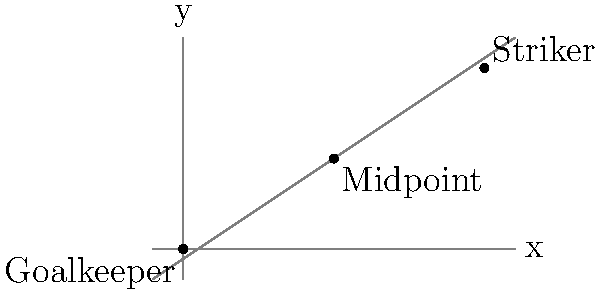In a football match, the goalkeeper is positioned at coordinates (0,0) and the striker at (10,6). To optimize the defender's positioning, you need to find the midpoint between these two players. What are the coordinates of this midpoint? To find the midpoint between two points, we use the midpoint formula:

$$(x_{midpoint}, y_{midpoint}) = (\frac{x_1 + x_2}{2}, \frac{y_1 + y_2}{2})$$

Where $(x_1, y_1)$ is the first point (goalkeeper) and $(x_2, y_2)$ is the second point (striker).

1. Identify the coordinates:
   Goalkeeper: $(x_1, y_1) = (0, 0)$
   Striker: $(x_2, y_2) = (10, 6)$

2. Calculate the x-coordinate of the midpoint:
   $$x_{midpoint} = \frac{x_1 + x_2}{2} = \frac{0 + 10}{2} = \frac{10}{2} = 5$$

3. Calculate the y-coordinate of the midpoint:
   $$y_{midpoint} = \frac{y_1 + y_2}{2} = \frac{0 + 6}{2} = \frac{6}{2} = 3$$

4. Combine the results:
   The midpoint coordinates are $(5, 3)$
Answer: (5, 3) 